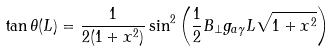Convert formula to latex. <formula><loc_0><loc_0><loc_500><loc_500>\tan { \theta ( L ) } = \frac { 1 } { 2 ( 1 + x ^ { 2 } ) } \sin ^ { 2 } { \left ( \frac { 1 } { 2 } B _ { \bot } g _ { a \gamma } L \sqrt { 1 + x ^ { 2 } } \right ) }</formula> 